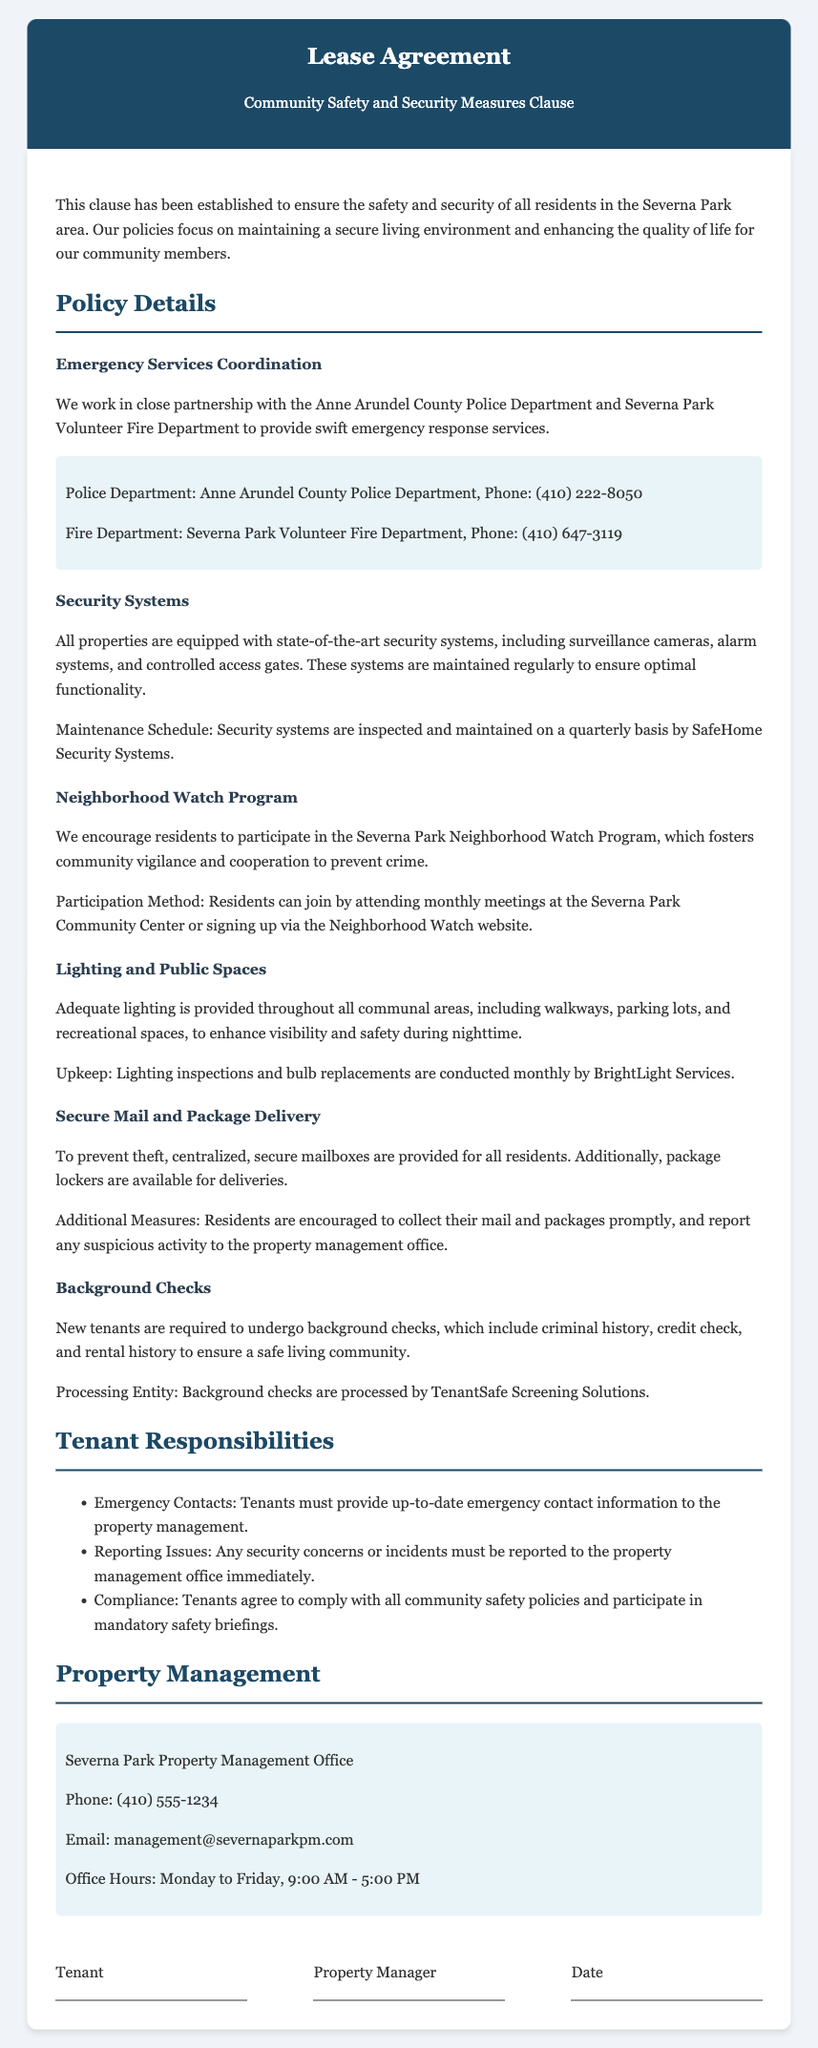What is the contact number for the Anne Arundel County Police Department? The document lists the police department's contact number for emergency services coordination.
Answer: (410) 222-8050 How often are security systems inspected? The document states the maintenance schedule for security systems in the property.
Answer: Quarterly What program encourages community vigilance? The document mentions a specific program that promotes neighborhood safety.
Answer: Neighborhood Watch Program What type of delivery security is provided for residents? The document describes measures taken to prevent theft concerning deliveries.
Answer: Secure mailboxes and package lockers What entity processes background checks for new tenants? The document specifies the company responsible for tenant background checks.
Answer: TenantSafe Screening Solutions How should tenants report security issues? The document outlines the procedure for tenants to communicate security concerns.
Answer: Immediately to the property management office What is the phone number for the Severna Park Property Management Office? The document contains the contact information for the property management office.
Answer: (410) 555-1234 What is one of the tenant responsibilities mentioned in the document? The document lists specific responsibilities that tenants must adhere to in relation to community safety.
Answer: Reporting security concerns 